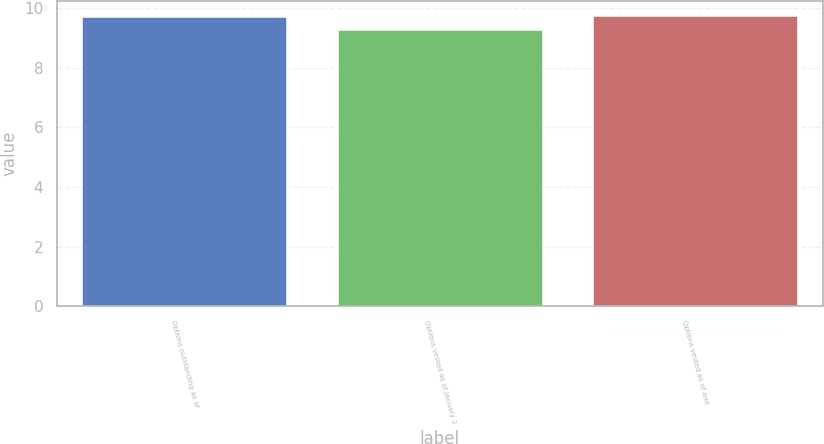Convert chart. <chart><loc_0><loc_0><loc_500><loc_500><bar_chart><fcel>Options outstanding as of<fcel>Options vested as of January 3<fcel>Options vested as of and<nl><fcel>9.71<fcel>9.28<fcel>9.75<nl></chart> 